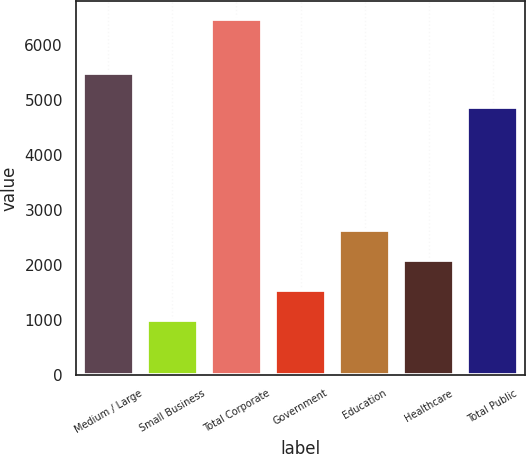Convert chart to OTSL. <chart><loc_0><loc_0><loc_500><loc_500><bar_chart><fcel>Medium / Large<fcel>Small Business<fcel>Total Corporate<fcel>Government<fcel>Education<fcel>Healthcare<fcel>Total Public<nl><fcel>5485.4<fcel>990.1<fcel>6475.5<fcel>1538.64<fcel>2635.72<fcel>2087.18<fcel>4879.4<nl></chart> 